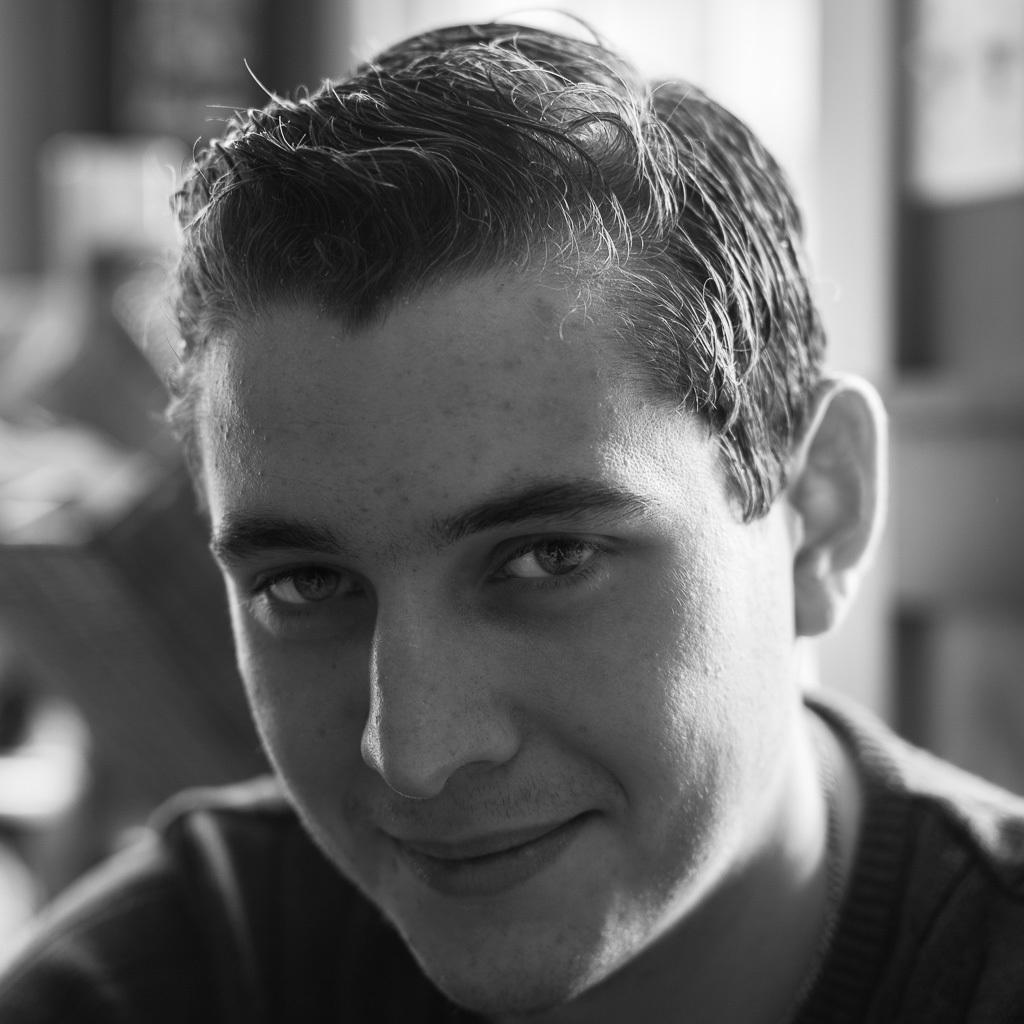Who is the main subject in the image? There is a man in the center of the image. What is the man doing in the image? The man is smiling. What type of cactus can be seen in the background of the image? There is no cactus present in the image; it only features a man in the center. 